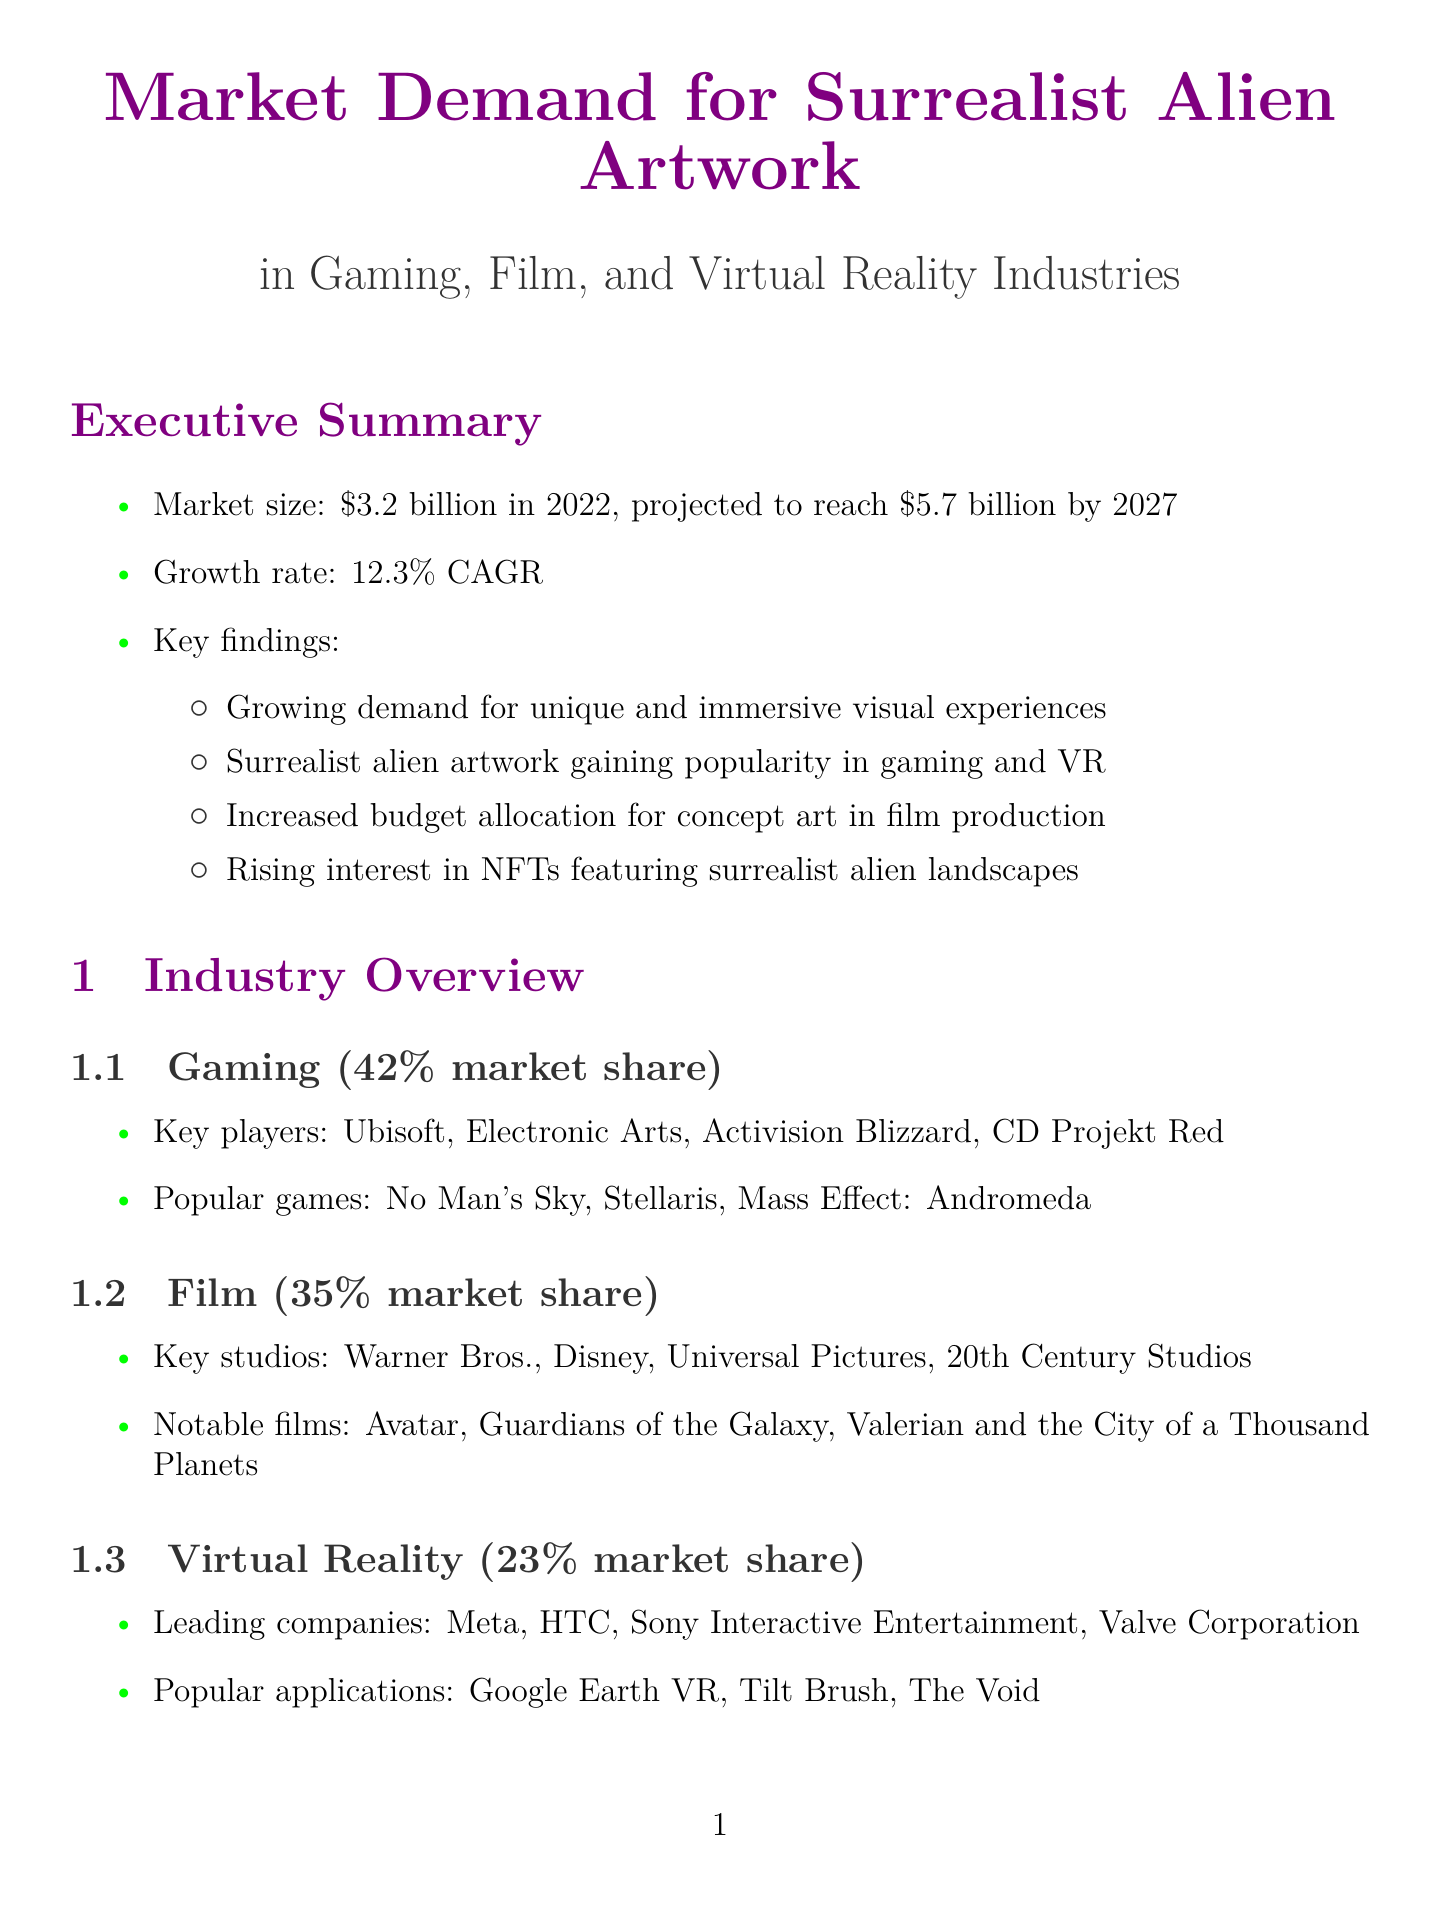What is the market size for surrealist alien artwork in 2022? The document states that the market size was $3.2 billion in 2022.
Answer: $3.2 billion What is the projected market size by 2027? The document indicates that the market size is projected to reach $5.7 billion by 2027.
Answer: $5.7 billion Which gaming company is mentioned as a key player? The document lists Ubisoft as a key player in the gaming industry.
Answer: Ubisoft What percentage of the market share does the film industry hold? According to the document, the film industry holds a 35% market share.
Answer: 35% Which artist is recognized for their impact in the film "Prometheus"? The document notes H.R. Giger as the artist behind the impact in "Prometheus."
Answer: H.R. Giger What is one of the demand drivers mentioned in the report? The document lists "Increasing interest in science fiction and space exploration" as a demand driver.
Answer: Increasing interest in science fiction and space exploration What is one challenge for artists in this market? The document states that "Oversaturation of generic alien designs" is a market challenge.
Answer: Oversaturation of generic alien designs What is a recommendation for artists in emerging markets? The document recommends exploring opportunities in "NFTs and metaverse projects."
Answer: NFTs and metaverse projects What collaboration trend is anticipated for the future? The document suggests "collaboration between traditional artists and technology companies" as a future trend.
Answer: Collaboration between traditional artists and technology companies 